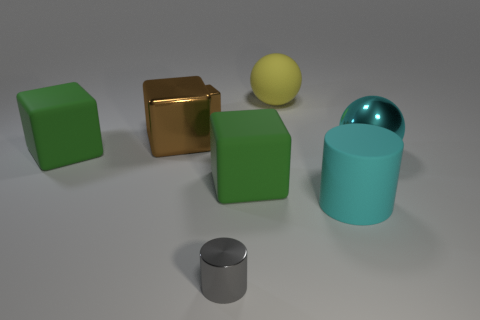Add 2 tiny gray metal objects. How many objects exist? 10 Subtract all cylinders. How many objects are left? 6 Subtract 1 cyan cylinders. How many objects are left? 7 Subtract all green rubber cubes. Subtract all big cylinders. How many objects are left? 5 Add 3 brown metal objects. How many brown metal objects are left? 5 Add 2 gray metal cylinders. How many gray metal cylinders exist? 3 